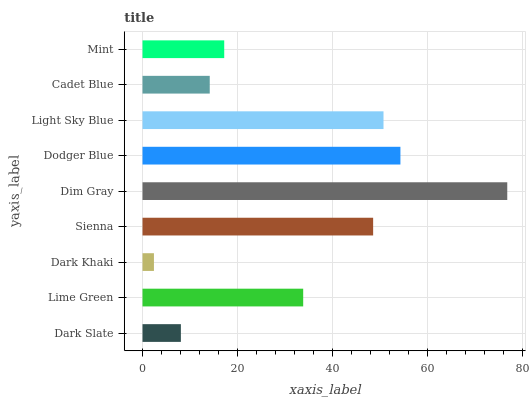Is Dark Khaki the minimum?
Answer yes or no. Yes. Is Dim Gray the maximum?
Answer yes or no. Yes. Is Lime Green the minimum?
Answer yes or no. No. Is Lime Green the maximum?
Answer yes or no. No. Is Lime Green greater than Dark Slate?
Answer yes or no. Yes. Is Dark Slate less than Lime Green?
Answer yes or no. Yes. Is Dark Slate greater than Lime Green?
Answer yes or no. No. Is Lime Green less than Dark Slate?
Answer yes or no. No. Is Lime Green the high median?
Answer yes or no. Yes. Is Lime Green the low median?
Answer yes or no. Yes. Is Dodger Blue the high median?
Answer yes or no. No. Is Dim Gray the low median?
Answer yes or no. No. 